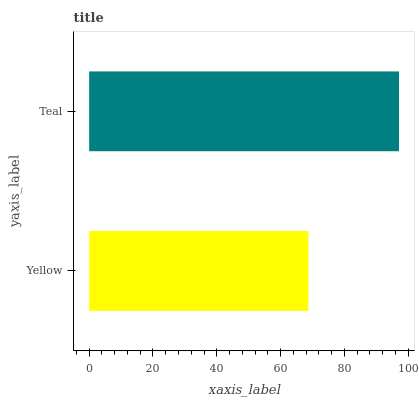Is Yellow the minimum?
Answer yes or no. Yes. Is Teal the maximum?
Answer yes or no. Yes. Is Teal the minimum?
Answer yes or no. No. Is Teal greater than Yellow?
Answer yes or no. Yes. Is Yellow less than Teal?
Answer yes or no. Yes. Is Yellow greater than Teal?
Answer yes or no. No. Is Teal less than Yellow?
Answer yes or no. No. Is Teal the high median?
Answer yes or no. Yes. Is Yellow the low median?
Answer yes or no. Yes. Is Yellow the high median?
Answer yes or no. No. Is Teal the low median?
Answer yes or no. No. 